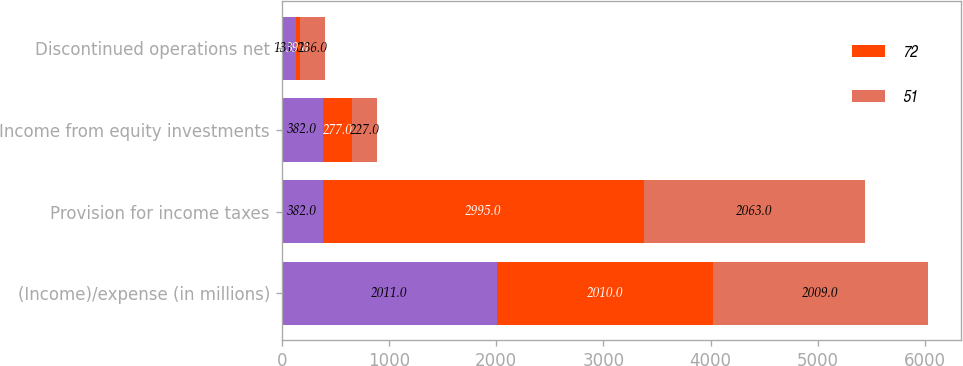Convert chart. <chart><loc_0><loc_0><loc_500><loc_500><stacked_bar_chart><ecel><fcel>(Income)/expense (in millions)<fcel>Provision for income taxes<fcel>Income from equity investments<fcel>Discontinued operations net<nl><fcel>nan<fcel>2011<fcel>382<fcel>382<fcel>131<nl><fcel>72<fcel>2010<fcel>2995<fcel>277<fcel>39<nl><fcel>51<fcel>2009<fcel>2063<fcel>227<fcel>236<nl></chart> 